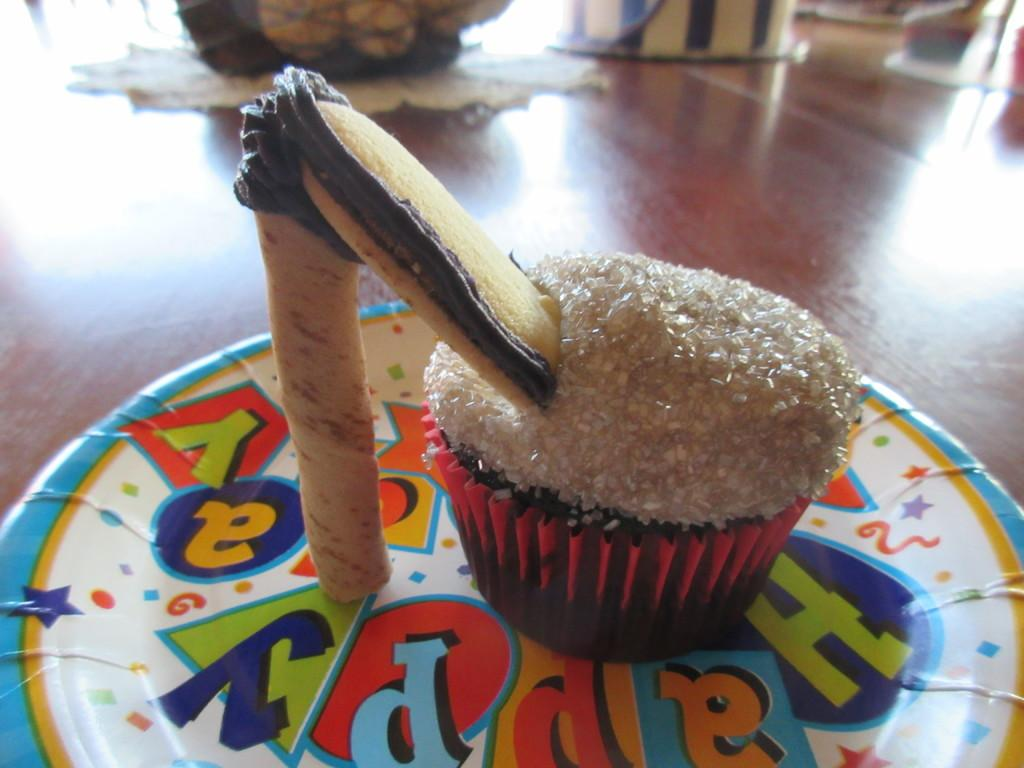What type of dessert is featured in the image? There is a cupcake with a wafer in the image. How is the cupcake presented? The cupcake is on a plate. Where is the plate located? The plate is placed on a table. Can you describe the unspecified objects at the top of the image? Unfortunately, the facts provided do not give any details about the objects at the top of the image. What type of ring is the cupcake wearing in the image? There is no ring present in the image; it features a cupcake with a wafer on a plate. 